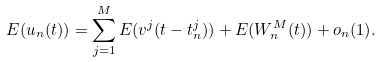Convert formula to latex. <formula><loc_0><loc_0><loc_500><loc_500>E ( u _ { n } ( t ) ) = \sum _ { j = 1 } ^ { M } E ( v ^ { j } ( t - t _ { n } ^ { j } ) ) + E ( W _ { n } ^ { M } ( t ) ) + o _ { n } ( 1 ) .</formula> 